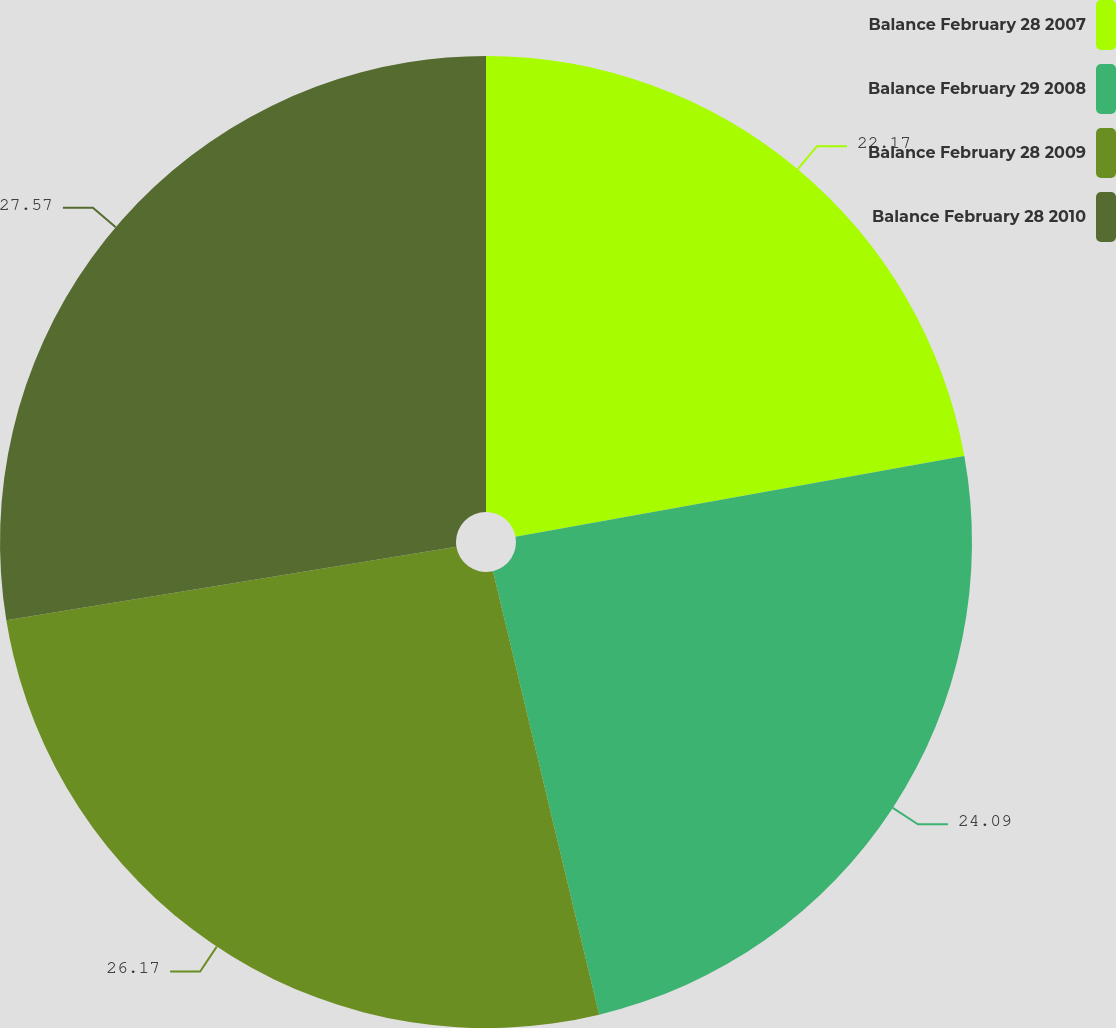Convert chart. <chart><loc_0><loc_0><loc_500><loc_500><pie_chart><fcel>Balance February 28 2007<fcel>Balance February 29 2008<fcel>Balance February 28 2009<fcel>Balance February 28 2010<nl><fcel>22.17%<fcel>24.09%<fcel>26.17%<fcel>27.57%<nl></chart> 